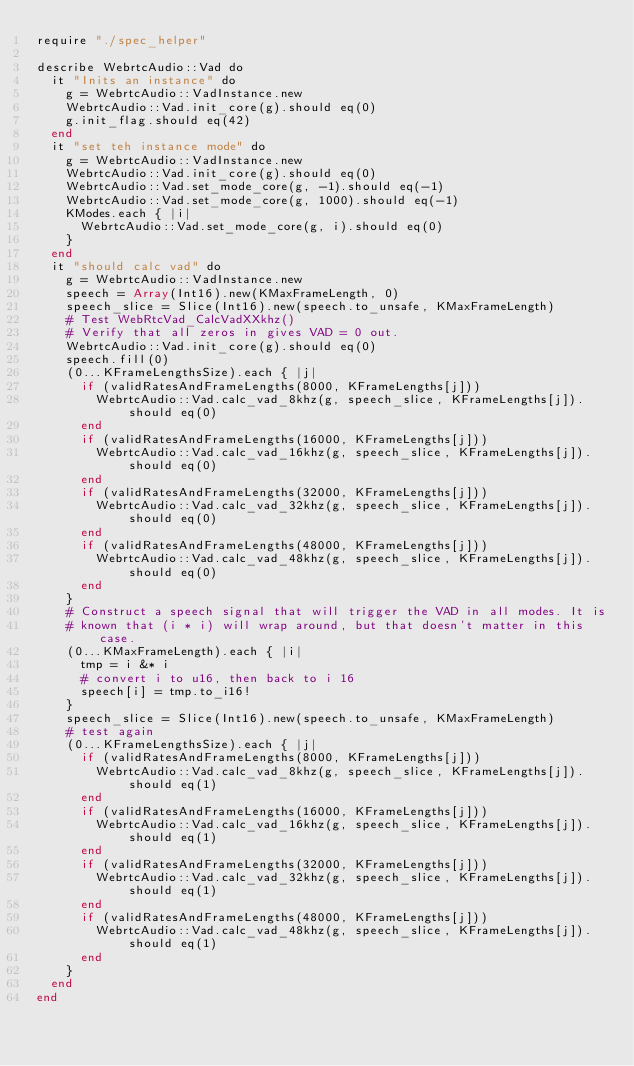<code> <loc_0><loc_0><loc_500><loc_500><_Crystal_>require "./spec_helper"

describe WebrtcAudio::Vad do
  it "Inits an instance" do
    g = WebrtcAudio::VadInstance.new
    WebrtcAudio::Vad.init_core(g).should eq(0)
    g.init_flag.should eq(42)
  end
  it "set teh instance mode" do
    g = WebrtcAudio::VadInstance.new
    WebrtcAudio::Vad.init_core(g).should eq(0)
    WebrtcAudio::Vad.set_mode_core(g, -1).should eq(-1)
    WebrtcAudio::Vad.set_mode_core(g, 1000).should eq(-1)
    KModes.each { |i|
      WebrtcAudio::Vad.set_mode_core(g, i).should eq(0)
    }
  end
  it "should calc vad" do
    g = WebrtcAudio::VadInstance.new
    speech = Array(Int16).new(KMaxFrameLength, 0)
    speech_slice = Slice(Int16).new(speech.to_unsafe, KMaxFrameLength)
    # Test WebRtcVad_CalcVadXXkhz()
    # Verify that all zeros in gives VAD = 0 out.
    WebrtcAudio::Vad.init_core(g).should eq(0)
    speech.fill(0)
    (0...KFrameLengthsSize).each { |j|
      if (validRatesAndFrameLengths(8000, KFrameLengths[j]))
        WebrtcAudio::Vad.calc_vad_8khz(g, speech_slice, KFrameLengths[j]).should eq(0)
      end
      if (validRatesAndFrameLengths(16000, KFrameLengths[j]))
        WebrtcAudio::Vad.calc_vad_16khz(g, speech_slice, KFrameLengths[j]).should eq(0)
      end
      if (validRatesAndFrameLengths(32000, KFrameLengths[j]))
        WebrtcAudio::Vad.calc_vad_32khz(g, speech_slice, KFrameLengths[j]).should eq(0)
      end
      if (validRatesAndFrameLengths(48000, KFrameLengths[j]))
        WebrtcAudio::Vad.calc_vad_48khz(g, speech_slice, KFrameLengths[j]).should eq(0)
      end
    }
    # Construct a speech signal that will trigger the VAD in all modes. It is
    # known that (i * i) will wrap around, but that doesn't matter in this case.
    (0...KMaxFrameLength).each { |i|
      tmp = i &* i
      # convert i to u16, then back to i 16
      speech[i] = tmp.to_i16!
    }
    speech_slice = Slice(Int16).new(speech.to_unsafe, KMaxFrameLength)
    # test again
    (0...KFrameLengthsSize).each { |j|
      if (validRatesAndFrameLengths(8000, KFrameLengths[j]))
        WebrtcAudio::Vad.calc_vad_8khz(g, speech_slice, KFrameLengths[j]).should eq(1)
      end
      if (validRatesAndFrameLengths(16000, KFrameLengths[j]))
        WebrtcAudio::Vad.calc_vad_16khz(g, speech_slice, KFrameLengths[j]).should eq(1)
      end
      if (validRatesAndFrameLengths(32000, KFrameLengths[j]))
        WebrtcAudio::Vad.calc_vad_32khz(g, speech_slice, KFrameLengths[j]).should eq(1)
      end
      if (validRatesAndFrameLengths(48000, KFrameLengths[j]))
        WebrtcAudio::Vad.calc_vad_48khz(g, speech_slice, KFrameLengths[j]).should eq(1)
      end
    }
  end
end
</code> 